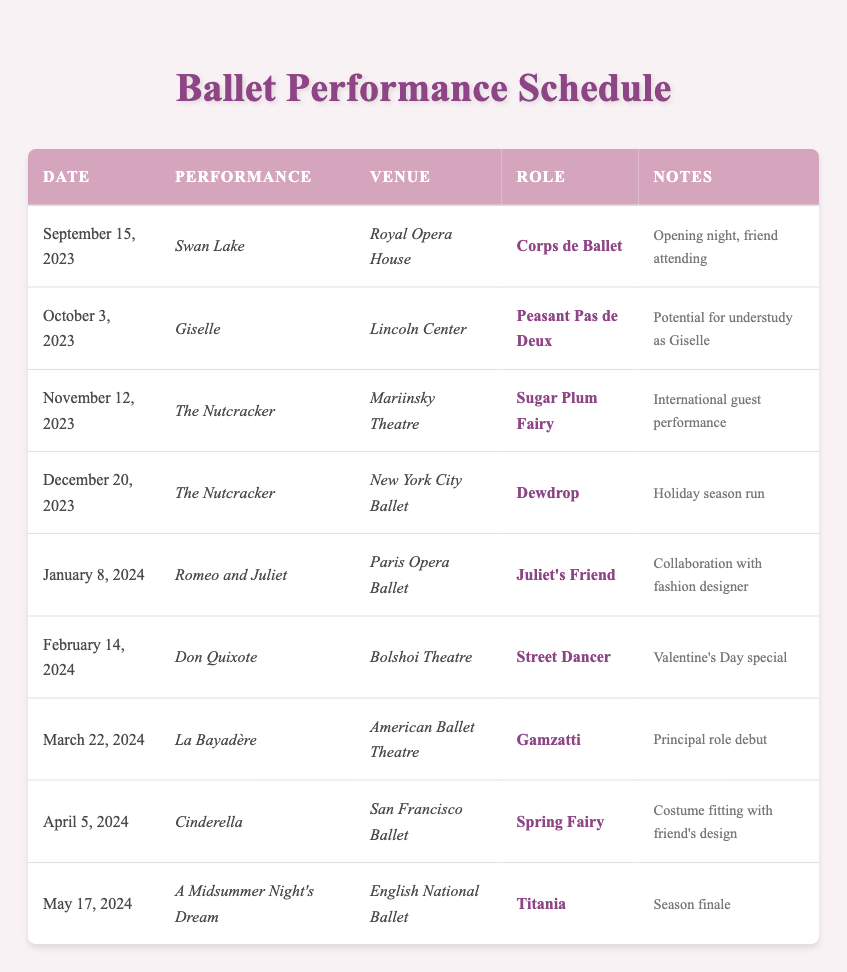What is the venue for the performance on October 3, 2023? The table lists the venue for each performance by date. Under the row for October 3, 2023, the venue is given as Lincoln Center.
Answer: Lincoln Center How many performances are scheduled for December 2023? The table has multiple entries for December. Upon review, there is one performance scheduled on December 20, 2023, which is The Nutcracker.
Answer: 1 Is the role of the performer in Swan Lake a principal role? By examining the role listed in the row for Swan Lake on September 15, 2023, it is stated as Corps de Ballet, which is not a principal role. Therefore, the statement is false.
Answer: No Which performance features a collaboration with a fashion designer? The table indicates that Romeo and Juliet, performed on January 8, 2024, includes a note about a collaboration with a fashion designer.
Answer: Romeo and Juliet What is the total number of performances scheduled from September 2023 to April 2024? First, count the number of performances in the relevant time frame by looking at the dates in the table. The performances during this period are Swan Lake, Giselle, The Nutcracker, Romeo and Juliet, Don Quixote, La Bayadère, and Cinderella. This amounts to a total of seven performances.
Answer: 7 Which role in The Nutcracker is associated with the international guest performance? The table specifies that the performance of The Nutcracker on November 12, 2023, features the role of Sugar Plum Fairy and is noted for its international guest performance.
Answer: Sugar Plum Fairy What is the role of the performer in A Midsummer Night's Dream, and what is significant about this performance? A Midsummer Night's Dream is performed on May 17, 2024, and the role listed is Titania. Additionally, it is noted as the season finale, indicating its significance in the season.
Answer: Titania, season finale How many performances are scheduled in February 2024? By examining just the rows for February, there is one performance: Don Quixote on February 14, 2024, which means there is only one performance scheduled in February 2024.
Answer: 1 What is the earliest performance date mentioned in the table, and what is the performance title for that date? The earliest performance date mentioned is September 15, 2023, and the corresponding performance title is Swan Lake.
Answer: September 15, 2023, Swan Lake 